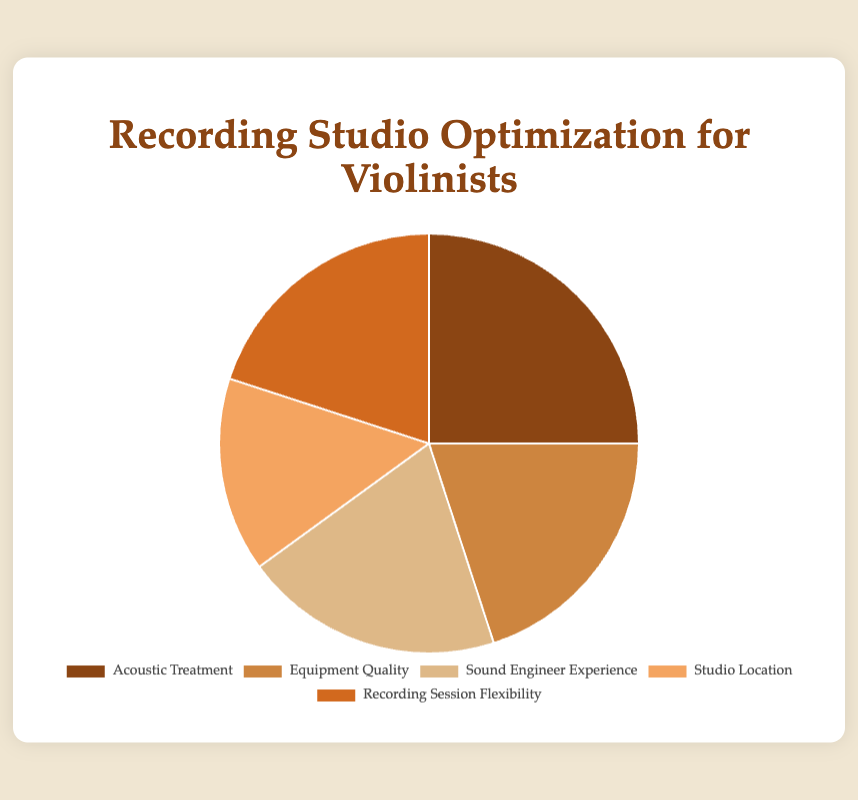What percentage of the total does Acoustic Treatment and Recording Session Flexibility combined represent? To find the combined percentage, add the percentages of Acoustic Treatment (25%) and Recording Session Flexibility (20%), which equals 45%.
Answer: 45% Which two categories have equal percentages? Identify the two categories with the same percentage values from the pie chart. Equipment Quality, Sound Engineer Experience, and Recording Session Flexibility all have a percentage of 20%. However, the question asks for two, so we can refer to any pair among them.
Answer: Equipment Quality and Sound Engineer Experience Is Studio Location more or less than the total percentage of Acoustic Treatment and Equipment Quality combined? First add the percentages of Acoustic Treatment (25%) and Equipment Quality (20%) which gives 45%. Then, compare this with the percentage of Studio Location which is 15%. Since 15% is less than 45%, the answer is less.
Answer: Less What is the range of the percentages across all categories? The range is calculated by subtracting the smallest percentage from the largest. The smallest percentage is for Studio Location (15%) and the largest is for Acoustic Treatment (25%), so the range is 25% - 15% = 10%.
Answer: 10% Which visual attribute helps identify Acoustic Treatment quickly? Acoustic Treatment is represented by a distinct color and is the largest segment in the pie chart. The color assigned to Acoustic Treatment is brown, making it visually distinct.
Answer: Brown color and largest segment 